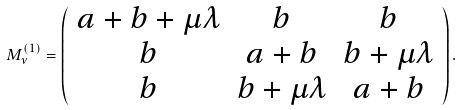Convert formula to latex. <formula><loc_0><loc_0><loc_500><loc_500>M ^ { ( 1 ) } _ { \nu } = \left ( \begin{array} { c c c } a + b + \mu \lambda & b & b \\ b & a + b & b + \mu \lambda \\ b & b + \mu \lambda & a + b \\ \end{array} \right ) .</formula> 